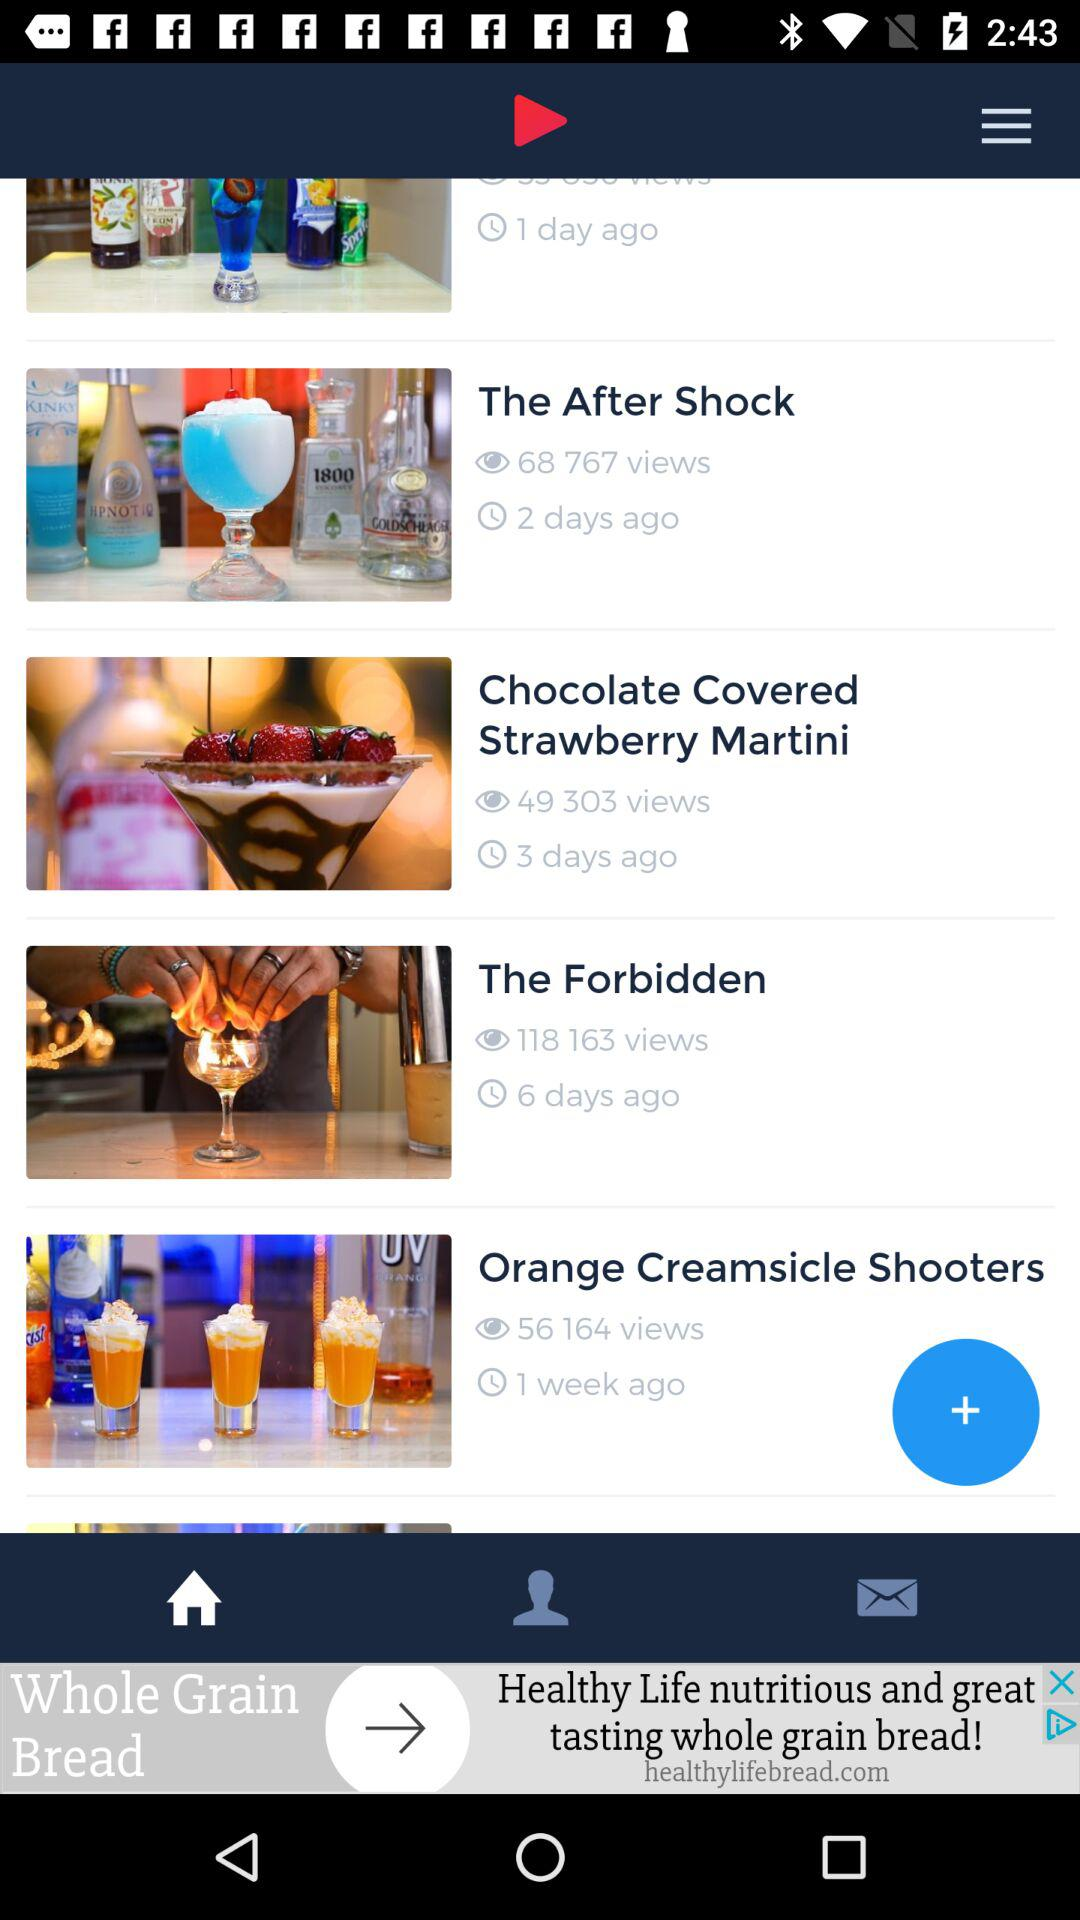When was the "Orange Creamsicle Shooters" video posted? The "Orange Creamsicle Shooters" video was posted 1 week ago. 